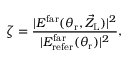<formula> <loc_0><loc_0><loc_500><loc_500>\zeta = \frac { | E ^ { f a r } ( \theta _ { r } , \vec { Z } _ { L } ) | ^ { 2 } } { | E _ { r e f e r } ^ { f a r } ( \theta _ { r } ) | ^ { 2 } } ,</formula> 